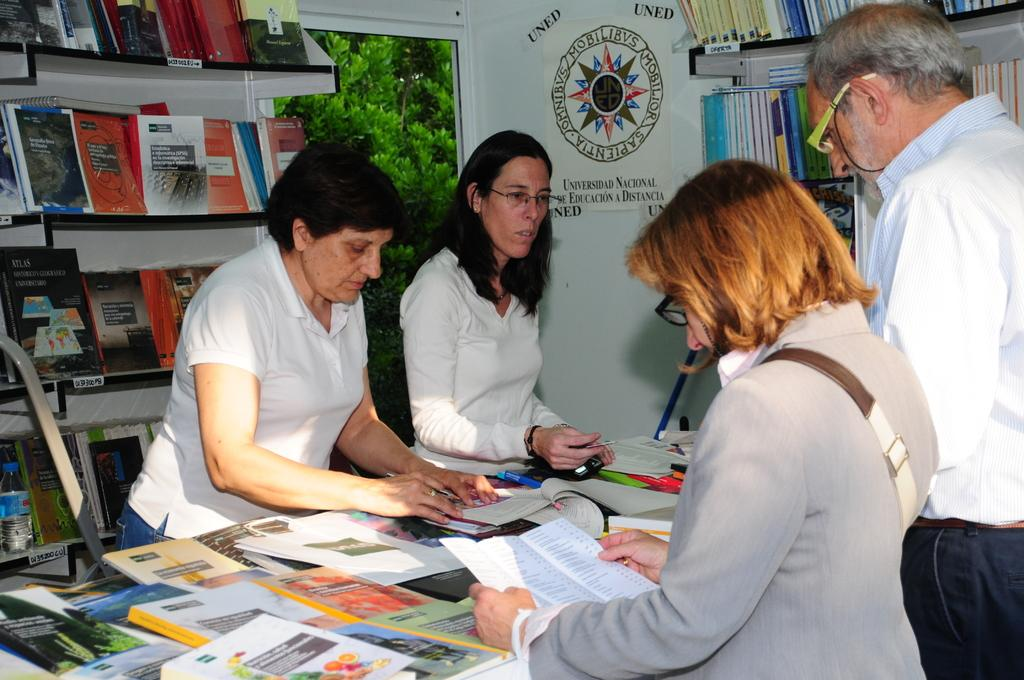<image>
Write a terse but informative summary of the picture. The people are representing the University called Universidad Nacional de Education a Distancia. 